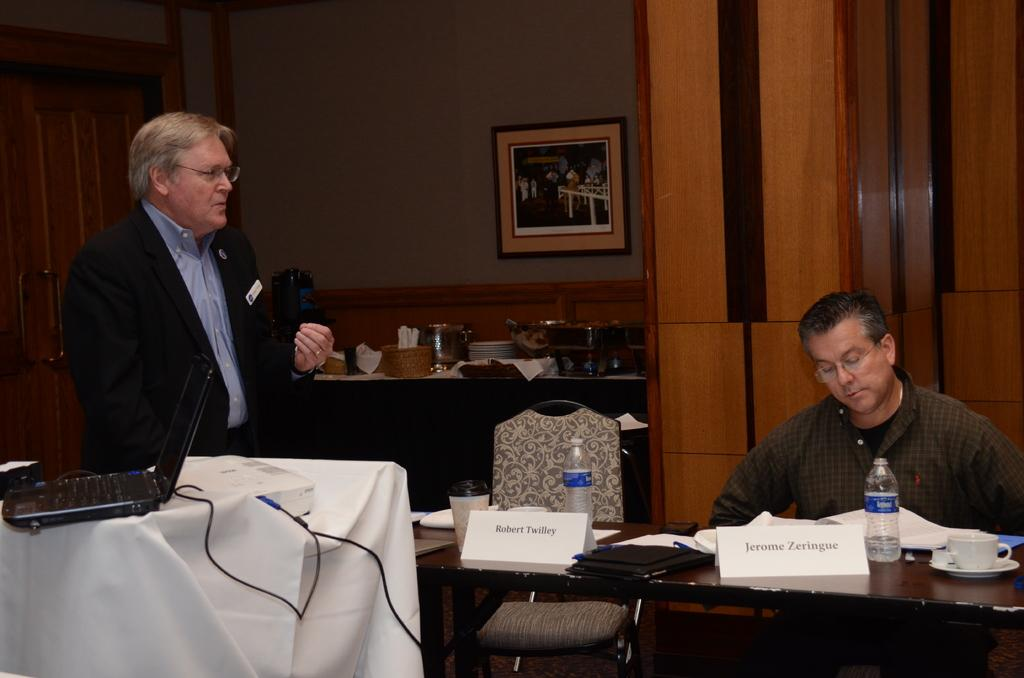How many people are in the room in the image? There are two men in the room. What is one man doing in the image? One man is standing beside a laptop. What is the other man doing in the image? The other man is sitting in a chair. What is the sitting man in front of? The sitting man is in front of a table. What items can be seen on the table? There are books and a coffee cup on the table. What type of bubble can be seen in the image? There is no bubble present in the image. How does the stomach of the standing man look in the image? The image does not show the stomach of the standing man, so it cannot be described. 